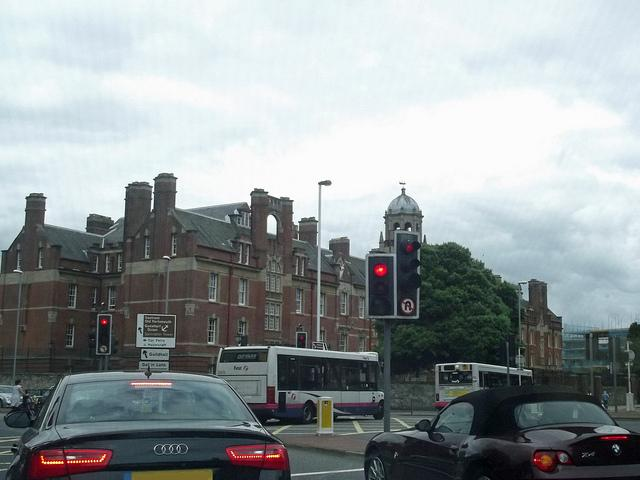What country are these cars manufactured in? Please explain your reasoning. germany. The logos on the backs of the cars are for audi and bmw. audi and bmw are german companies. 